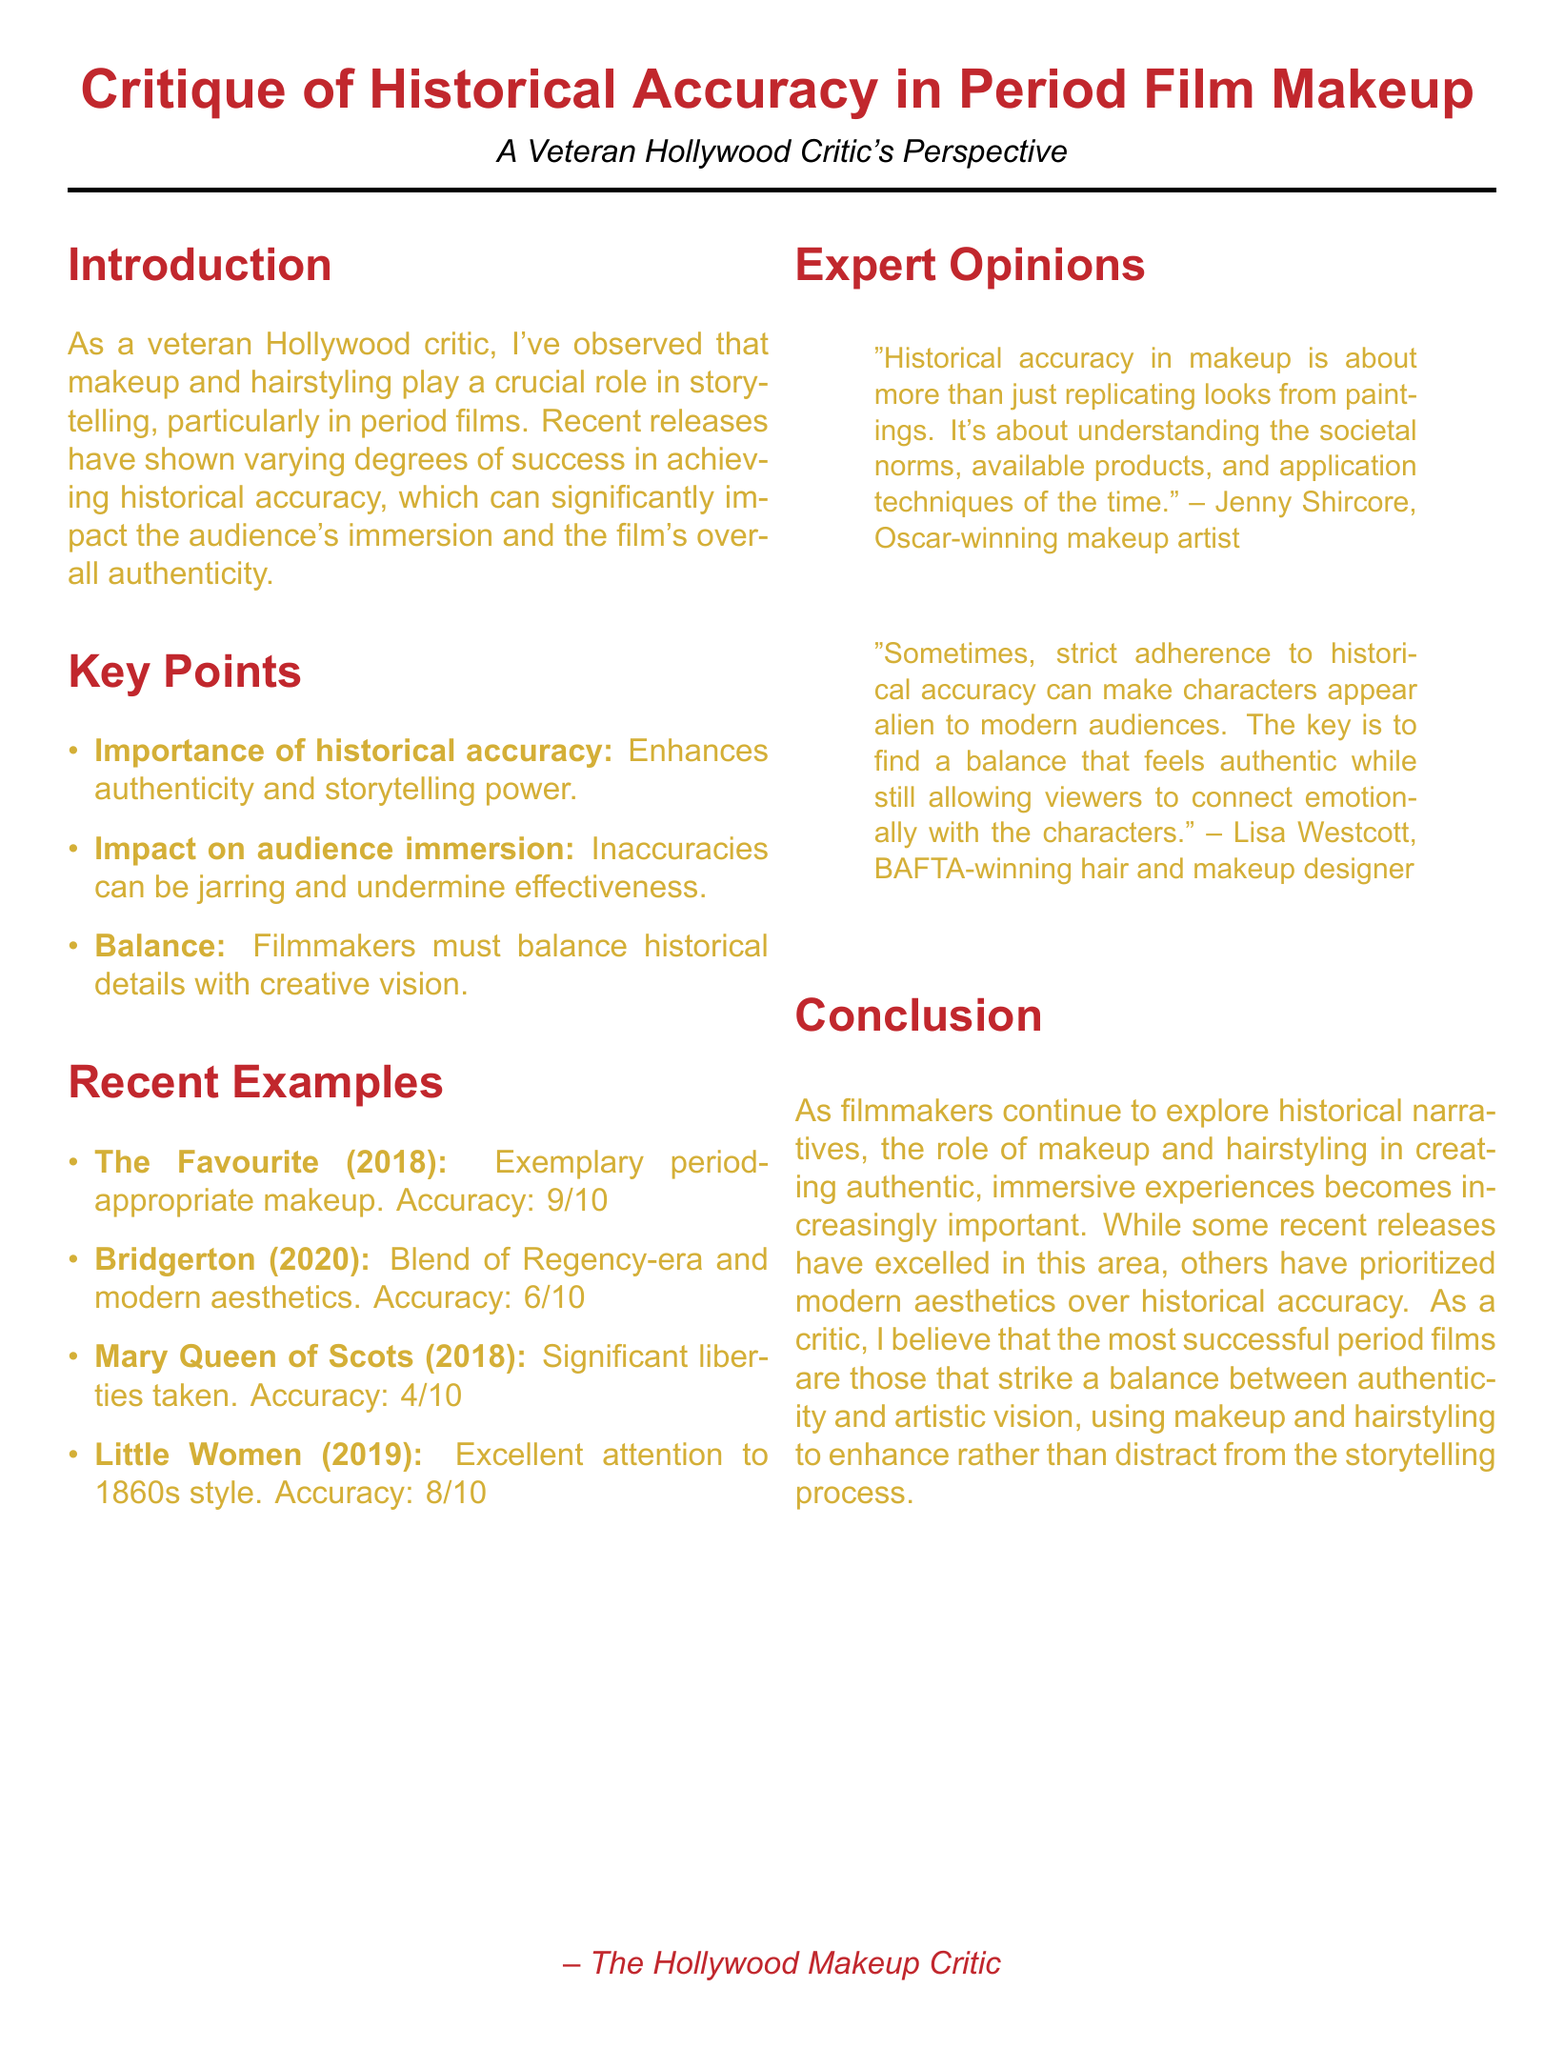What is the title of the document? The title is stated at the beginning of the document, outlining the main subject addressed.
Answer: Critique of Historical Accuracy in Period Film Makeup: Recent Examples What year was "The Favourite" released? The release year of "The Favourite" is mentioned in the section listing recent examples.
Answer: 2018 What is the accuracy rating of "Mary Queen of Scots"? The accuracy rating is provided in the critique of "Mary Queen of Scots."
Answer: 4 Who is the Oscar-winning makeup artist quoted in the document? The document includes a quote from an expert with an Oscar, describing the importance of understanding historical makeup.
Answer: Jenny Shircore What does the expert Lisa Westcott suggest about strict adherence to historical accuracy? The quote from Lisa Westcott discusses the implications of strict adherence to historical accuracy in relation to audience connection.
Answer: It can make characters appear alien to modern audiences How does "Bridgerton"'s makeup approach differ from strict historical accuracy? The critique of "Bridgerton" notes its unique visual style combining different aesthetics rather than being strictly accurate.
Answer: It blends Regency-era aesthetics with modern touches Which film is described as having excellent attention to detail in makeup and hairstyling reflective of the 1860s? The document lists films and their respective makeup critiques, specifically pointing out attention to detail in one particular film.
Answer: Little Women What is the main critique of makeup in "Mary Queen of Scots"? Critiques are provided for each film, highlighting specific aspects, particularly focusing on the bold choices made in makeup for this film.
Answer: Significant liberties taken 